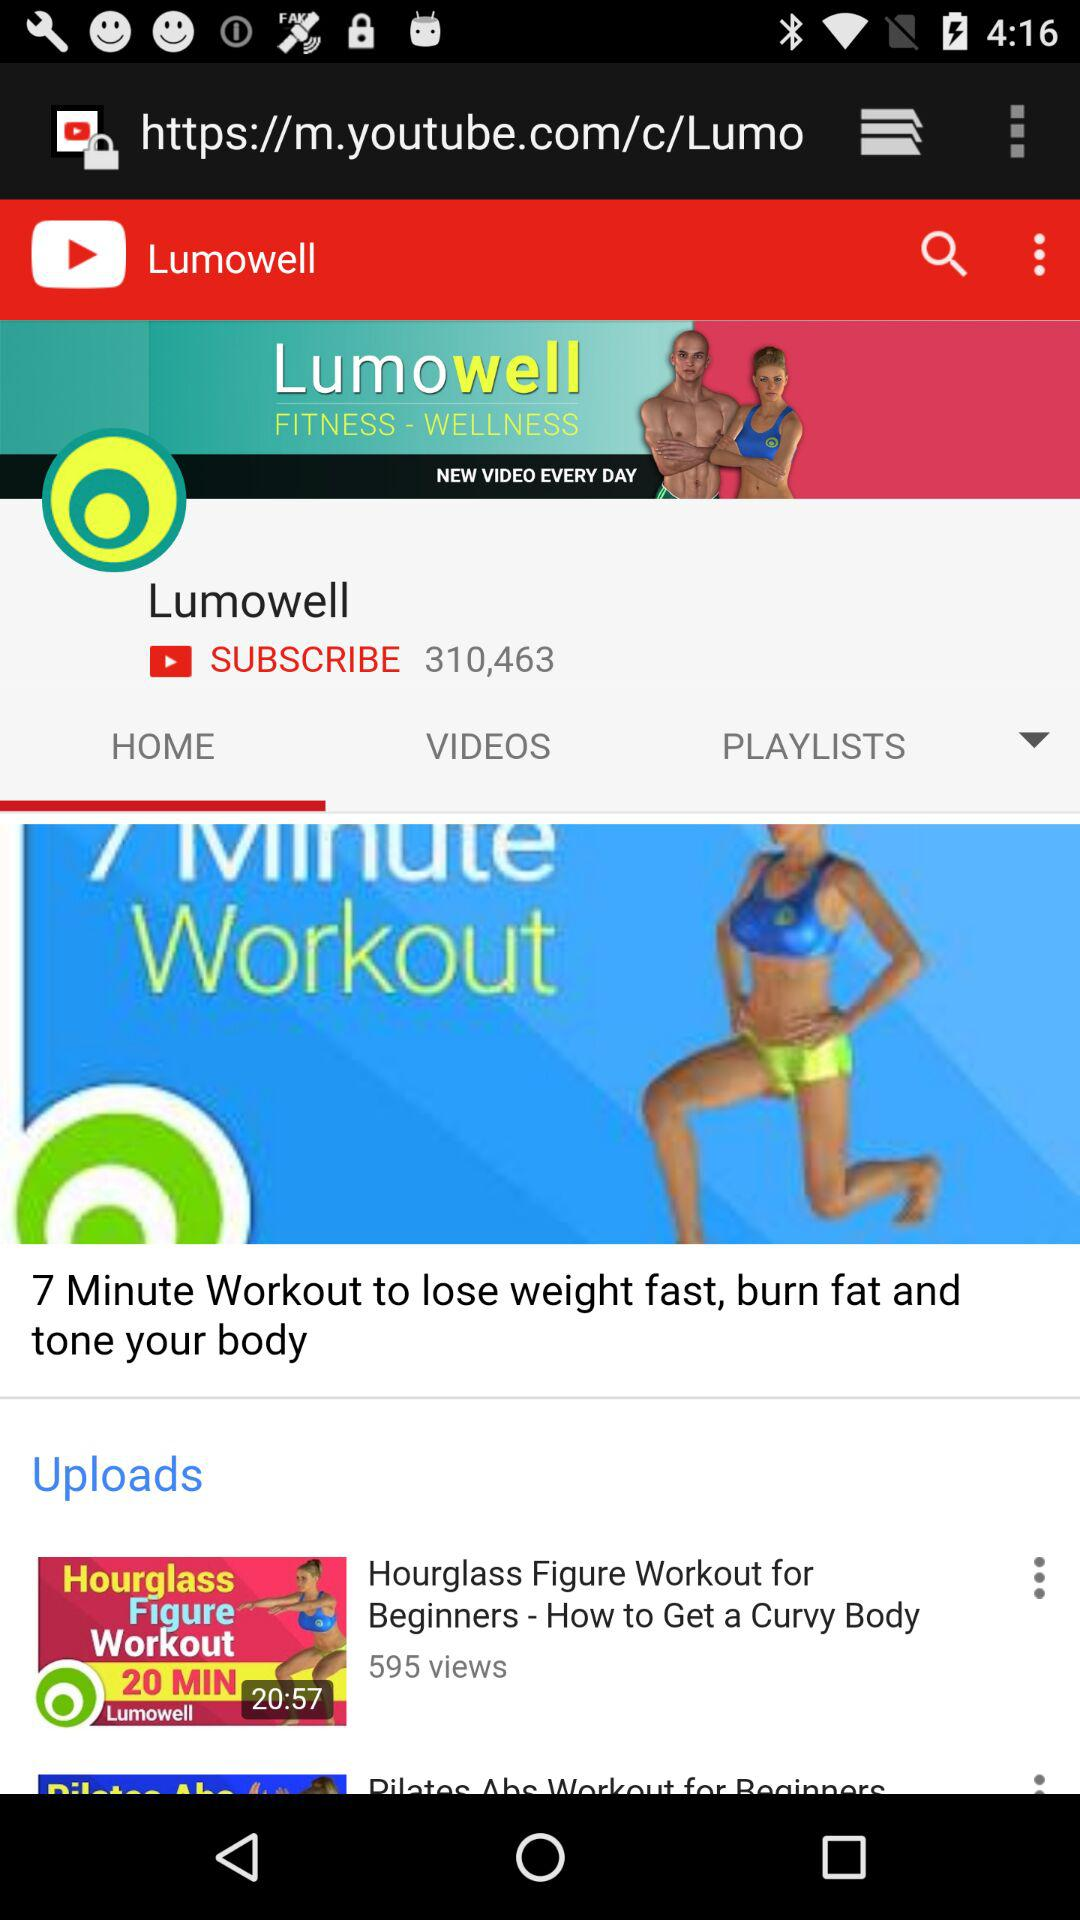How many views are on "How to Get a Curvy Body"? There are 595 views. 